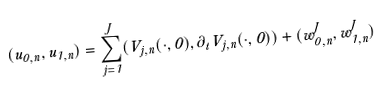<formula> <loc_0><loc_0><loc_500><loc_500>( u _ { 0 , n } , u _ { 1 , n } ) = \sum _ { j = 1 } ^ { J } ( V _ { j , n } ( \cdot , 0 ) , \partial _ { t } V _ { j , n } ( \cdot , 0 ) ) + ( w _ { 0 , n } ^ { J } , w _ { 1 , n } ^ { J } )</formula> 